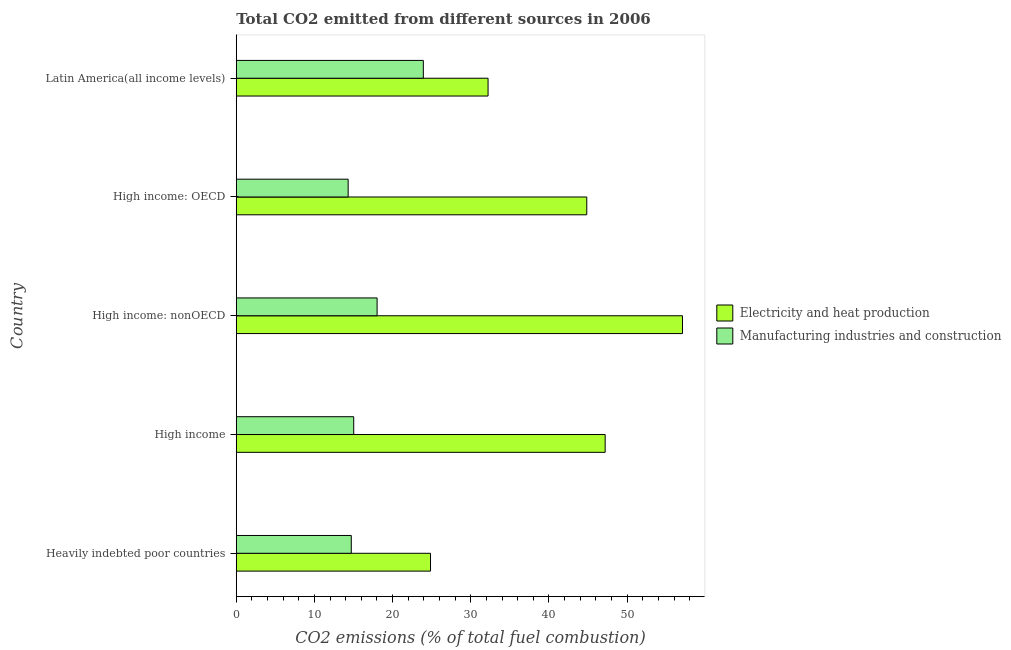How many different coloured bars are there?
Offer a very short reply. 2. How many groups of bars are there?
Your answer should be compact. 5. Are the number of bars per tick equal to the number of legend labels?
Provide a short and direct response. Yes. Are the number of bars on each tick of the Y-axis equal?
Offer a very short reply. Yes. How many bars are there on the 5th tick from the top?
Make the answer very short. 2. What is the label of the 4th group of bars from the top?
Provide a succinct answer. High income. In how many cases, is the number of bars for a given country not equal to the number of legend labels?
Offer a very short reply. 0. What is the co2 emissions due to electricity and heat production in Heavily indebted poor countries?
Your answer should be compact. 24.85. Across all countries, what is the maximum co2 emissions due to manufacturing industries?
Provide a short and direct response. 23.93. Across all countries, what is the minimum co2 emissions due to manufacturing industries?
Give a very brief answer. 14.31. In which country was the co2 emissions due to electricity and heat production maximum?
Give a very brief answer. High income: nonOECD. In which country was the co2 emissions due to electricity and heat production minimum?
Offer a very short reply. Heavily indebted poor countries. What is the total co2 emissions due to manufacturing industries in the graph?
Give a very brief answer. 86. What is the difference between the co2 emissions due to manufacturing industries in High income and the co2 emissions due to electricity and heat production in High income: nonOECD?
Offer a terse response. -42.06. What is the average co2 emissions due to electricity and heat production per country?
Ensure brevity in your answer.  41.24. What is the difference between the co2 emissions due to electricity and heat production and co2 emissions due to manufacturing industries in Heavily indebted poor countries?
Give a very brief answer. 10.14. In how many countries, is the co2 emissions due to electricity and heat production greater than 14 %?
Provide a short and direct response. 5. What is the ratio of the co2 emissions due to electricity and heat production in Heavily indebted poor countries to that in High income?
Ensure brevity in your answer.  0.53. Is the co2 emissions due to manufacturing industries in Heavily indebted poor countries less than that in High income: OECD?
Your response must be concise. No. What is the difference between the highest and the second highest co2 emissions due to electricity and heat production?
Your response must be concise. 9.89. What is the difference between the highest and the lowest co2 emissions due to manufacturing industries?
Give a very brief answer. 9.62. In how many countries, is the co2 emissions due to electricity and heat production greater than the average co2 emissions due to electricity and heat production taken over all countries?
Ensure brevity in your answer.  3. Is the sum of the co2 emissions due to manufacturing industries in High income: OECD and High income: nonOECD greater than the maximum co2 emissions due to electricity and heat production across all countries?
Offer a terse response. No. What does the 1st bar from the top in Heavily indebted poor countries represents?
Your answer should be compact. Manufacturing industries and construction. What does the 2nd bar from the bottom in High income represents?
Your response must be concise. Manufacturing industries and construction. Are all the bars in the graph horizontal?
Your answer should be very brief. Yes. How many countries are there in the graph?
Give a very brief answer. 5. What is the difference between two consecutive major ticks on the X-axis?
Your answer should be compact. 10. Are the values on the major ticks of X-axis written in scientific E-notation?
Provide a short and direct response. No. Does the graph contain grids?
Your answer should be compact. No. How many legend labels are there?
Provide a succinct answer. 2. How are the legend labels stacked?
Make the answer very short. Vertical. What is the title of the graph?
Your answer should be very brief. Total CO2 emitted from different sources in 2006. Does "Ages 15-24" appear as one of the legend labels in the graph?
Keep it short and to the point. No. What is the label or title of the X-axis?
Give a very brief answer. CO2 emissions (% of total fuel combustion). What is the label or title of the Y-axis?
Ensure brevity in your answer.  Country. What is the CO2 emissions (% of total fuel combustion) of Electricity and heat production in Heavily indebted poor countries?
Give a very brief answer. 24.85. What is the CO2 emissions (% of total fuel combustion) of Manufacturing industries and construction in Heavily indebted poor countries?
Keep it short and to the point. 14.71. What is the CO2 emissions (% of total fuel combustion) of Electricity and heat production in High income?
Provide a short and direct response. 47.19. What is the CO2 emissions (% of total fuel combustion) in Manufacturing industries and construction in High income?
Offer a terse response. 15.03. What is the CO2 emissions (% of total fuel combustion) in Electricity and heat production in High income: nonOECD?
Make the answer very short. 57.08. What is the CO2 emissions (% of total fuel combustion) in Manufacturing industries and construction in High income: nonOECD?
Provide a short and direct response. 18.02. What is the CO2 emissions (% of total fuel combustion) in Electricity and heat production in High income: OECD?
Offer a very short reply. 44.84. What is the CO2 emissions (% of total fuel combustion) of Manufacturing industries and construction in High income: OECD?
Your response must be concise. 14.31. What is the CO2 emissions (% of total fuel combustion) in Electricity and heat production in Latin America(all income levels)?
Make the answer very short. 32.21. What is the CO2 emissions (% of total fuel combustion) of Manufacturing industries and construction in Latin America(all income levels)?
Offer a terse response. 23.93. Across all countries, what is the maximum CO2 emissions (% of total fuel combustion) of Electricity and heat production?
Offer a terse response. 57.08. Across all countries, what is the maximum CO2 emissions (% of total fuel combustion) in Manufacturing industries and construction?
Offer a very short reply. 23.93. Across all countries, what is the minimum CO2 emissions (% of total fuel combustion) of Electricity and heat production?
Provide a succinct answer. 24.85. Across all countries, what is the minimum CO2 emissions (% of total fuel combustion) of Manufacturing industries and construction?
Keep it short and to the point. 14.31. What is the total CO2 emissions (% of total fuel combustion) of Electricity and heat production in the graph?
Keep it short and to the point. 206.18. What is the total CO2 emissions (% of total fuel combustion) in Manufacturing industries and construction in the graph?
Offer a terse response. 86. What is the difference between the CO2 emissions (% of total fuel combustion) of Electricity and heat production in Heavily indebted poor countries and that in High income?
Your answer should be compact. -22.34. What is the difference between the CO2 emissions (% of total fuel combustion) in Manufacturing industries and construction in Heavily indebted poor countries and that in High income?
Your answer should be very brief. -0.31. What is the difference between the CO2 emissions (% of total fuel combustion) in Electricity and heat production in Heavily indebted poor countries and that in High income: nonOECD?
Ensure brevity in your answer.  -32.23. What is the difference between the CO2 emissions (% of total fuel combustion) in Manufacturing industries and construction in Heavily indebted poor countries and that in High income: nonOECD?
Your answer should be compact. -3.3. What is the difference between the CO2 emissions (% of total fuel combustion) in Electricity and heat production in Heavily indebted poor countries and that in High income: OECD?
Your answer should be compact. -19.99. What is the difference between the CO2 emissions (% of total fuel combustion) of Manufacturing industries and construction in Heavily indebted poor countries and that in High income: OECD?
Keep it short and to the point. 0.4. What is the difference between the CO2 emissions (% of total fuel combustion) of Electricity and heat production in Heavily indebted poor countries and that in Latin America(all income levels)?
Make the answer very short. -7.36. What is the difference between the CO2 emissions (% of total fuel combustion) of Manufacturing industries and construction in Heavily indebted poor countries and that in Latin America(all income levels)?
Your response must be concise. -9.22. What is the difference between the CO2 emissions (% of total fuel combustion) in Electricity and heat production in High income and that in High income: nonOECD?
Ensure brevity in your answer.  -9.89. What is the difference between the CO2 emissions (% of total fuel combustion) in Manufacturing industries and construction in High income and that in High income: nonOECD?
Make the answer very short. -2.99. What is the difference between the CO2 emissions (% of total fuel combustion) of Electricity and heat production in High income and that in High income: OECD?
Provide a short and direct response. 2.35. What is the difference between the CO2 emissions (% of total fuel combustion) of Manufacturing industries and construction in High income and that in High income: OECD?
Offer a terse response. 0.71. What is the difference between the CO2 emissions (% of total fuel combustion) of Electricity and heat production in High income and that in Latin America(all income levels)?
Keep it short and to the point. 14.98. What is the difference between the CO2 emissions (% of total fuel combustion) of Manufacturing industries and construction in High income and that in Latin America(all income levels)?
Ensure brevity in your answer.  -8.91. What is the difference between the CO2 emissions (% of total fuel combustion) of Electricity and heat production in High income: nonOECD and that in High income: OECD?
Give a very brief answer. 12.24. What is the difference between the CO2 emissions (% of total fuel combustion) in Manufacturing industries and construction in High income: nonOECD and that in High income: OECD?
Offer a terse response. 3.7. What is the difference between the CO2 emissions (% of total fuel combustion) in Electricity and heat production in High income: nonOECD and that in Latin America(all income levels)?
Make the answer very short. 24.87. What is the difference between the CO2 emissions (% of total fuel combustion) in Manufacturing industries and construction in High income: nonOECD and that in Latin America(all income levels)?
Your response must be concise. -5.92. What is the difference between the CO2 emissions (% of total fuel combustion) of Electricity and heat production in High income: OECD and that in Latin America(all income levels)?
Give a very brief answer. 12.63. What is the difference between the CO2 emissions (% of total fuel combustion) of Manufacturing industries and construction in High income: OECD and that in Latin America(all income levels)?
Offer a terse response. -9.62. What is the difference between the CO2 emissions (% of total fuel combustion) of Electricity and heat production in Heavily indebted poor countries and the CO2 emissions (% of total fuel combustion) of Manufacturing industries and construction in High income?
Offer a terse response. 9.83. What is the difference between the CO2 emissions (% of total fuel combustion) in Electricity and heat production in Heavily indebted poor countries and the CO2 emissions (% of total fuel combustion) in Manufacturing industries and construction in High income: nonOECD?
Offer a very short reply. 6.84. What is the difference between the CO2 emissions (% of total fuel combustion) in Electricity and heat production in Heavily indebted poor countries and the CO2 emissions (% of total fuel combustion) in Manufacturing industries and construction in High income: OECD?
Make the answer very short. 10.54. What is the difference between the CO2 emissions (% of total fuel combustion) in Electricity and heat production in Heavily indebted poor countries and the CO2 emissions (% of total fuel combustion) in Manufacturing industries and construction in Latin America(all income levels)?
Ensure brevity in your answer.  0.92. What is the difference between the CO2 emissions (% of total fuel combustion) in Electricity and heat production in High income and the CO2 emissions (% of total fuel combustion) in Manufacturing industries and construction in High income: nonOECD?
Provide a succinct answer. 29.18. What is the difference between the CO2 emissions (% of total fuel combustion) of Electricity and heat production in High income and the CO2 emissions (% of total fuel combustion) of Manufacturing industries and construction in High income: OECD?
Offer a terse response. 32.88. What is the difference between the CO2 emissions (% of total fuel combustion) of Electricity and heat production in High income and the CO2 emissions (% of total fuel combustion) of Manufacturing industries and construction in Latin America(all income levels)?
Your answer should be very brief. 23.26. What is the difference between the CO2 emissions (% of total fuel combustion) in Electricity and heat production in High income: nonOECD and the CO2 emissions (% of total fuel combustion) in Manufacturing industries and construction in High income: OECD?
Provide a short and direct response. 42.77. What is the difference between the CO2 emissions (% of total fuel combustion) in Electricity and heat production in High income: nonOECD and the CO2 emissions (% of total fuel combustion) in Manufacturing industries and construction in Latin America(all income levels)?
Give a very brief answer. 33.15. What is the difference between the CO2 emissions (% of total fuel combustion) in Electricity and heat production in High income: OECD and the CO2 emissions (% of total fuel combustion) in Manufacturing industries and construction in Latin America(all income levels)?
Offer a terse response. 20.91. What is the average CO2 emissions (% of total fuel combustion) of Electricity and heat production per country?
Offer a very short reply. 41.24. What is the average CO2 emissions (% of total fuel combustion) of Manufacturing industries and construction per country?
Your answer should be compact. 17.2. What is the difference between the CO2 emissions (% of total fuel combustion) in Electricity and heat production and CO2 emissions (% of total fuel combustion) in Manufacturing industries and construction in Heavily indebted poor countries?
Your answer should be compact. 10.14. What is the difference between the CO2 emissions (% of total fuel combustion) of Electricity and heat production and CO2 emissions (% of total fuel combustion) of Manufacturing industries and construction in High income?
Provide a succinct answer. 32.17. What is the difference between the CO2 emissions (% of total fuel combustion) of Electricity and heat production and CO2 emissions (% of total fuel combustion) of Manufacturing industries and construction in High income: nonOECD?
Offer a terse response. 39.07. What is the difference between the CO2 emissions (% of total fuel combustion) in Electricity and heat production and CO2 emissions (% of total fuel combustion) in Manufacturing industries and construction in High income: OECD?
Your answer should be very brief. 30.52. What is the difference between the CO2 emissions (% of total fuel combustion) of Electricity and heat production and CO2 emissions (% of total fuel combustion) of Manufacturing industries and construction in Latin America(all income levels)?
Offer a very short reply. 8.28. What is the ratio of the CO2 emissions (% of total fuel combustion) of Electricity and heat production in Heavily indebted poor countries to that in High income?
Keep it short and to the point. 0.53. What is the ratio of the CO2 emissions (% of total fuel combustion) of Manufacturing industries and construction in Heavily indebted poor countries to that in High income?
Ensure brevity in your answer.  0.98. What is the ratio of the CO2 emissions (% of total fuel combustion) in Electricity and heat production in Heavily indebted poor countries to that in High income: nonOECD?
Your response must be concise. 0.44. What is the ratio of the CO2 emissions (% of total fuel combustion) in Manufacturing industries and construction in Heavily indebted poor countries to that in High income: nonOECD?
Offer a terse response. 0.82. What is the ratio of the CO2 emissions (% of total fuel combustion) of Electricity and heat production in Heavily indebted poor countries to that in High income: OECD?
Your answer should be compact. 0.55. What is the ratio of the CO2 emissions (% of total fuel combustion) in Manufacturing industries and construction in Heavily indebted poor countries to that in High income: OECD?
Give a very brief answer. 1.03. What is the ratio of the CO2 emissions (% of total fuel combustion) in Electricity and heat production in Heavily indebted poor countries to that in Latin America(all income levels)?
Offer a very short reply. 0.77. What is the ratio of the CO2 emissions (% of total fuel combustion) in Manufacturing industries and construction in Heavily indebted poor countries to that in Latin America(all income levels)?
Provide a short and direct response. 0.61. What is the ratio of the CO2 emissions (% of total fuel combustion) of Electricity and heat production in High income to that in High income: nonOECD?
Make the answer very short. 0.83. What is the ratio of the CO2 emissions (% of total fuel combustion) of Manufacturing industries and construction in High income to that in High income: nonOECD?
Give a very brief answer. 0.83. What is the ratio of the CO2 emissions (% of total fuel combustion) in Electricity and heat production in High income to that in High income: OECD?
Your answer should be compact. 1.05. What is the ratio of the CO2 emissions (% of total fuel combustion) of Manufacturing industries and construction in High income to that in High income: OECD?
Give a very brief answer. 1.05. What is the ratio of the CO2 emissions (% of total fuel combustion) of Electricity and heat production in High income to that in Latin America(all income levels)?
Provide a succinct answer. 1.47. What is the ratio of the CO2 emissions (% of total fuel combustion) of Manufacturing industries and construction in High income to that in Latin America(all income levels)?
Provide a short and direct response. 0.63. What is the ratio of the CO2 emissions (% of total fuel combustion) of Electricity and heat production in High income: nonOECD to that in High income: OECD?
Keep it short and to the point. 1.27. What is the ratio of the CO2 emissions (% of total fuel combustion) in Manufacturing industries and construction in High income: nonOECD to that in High income: OECD?
Your response must be concise. 1.26. What is the ratio of the CO2 emissions (% of total fuel combustion) in Electricity and heat production in High income: nonOECD to that in Latin America(all income levels)?
Ensure brevity in your answer.  1.77. What is the ratio of the CO2 emissions (% of total fuel combustion) of Manufacturing industries and construction in High income: nonOECD to that in Latin America(all income levels)?
Your answer should be compact. 0.75. What is the ratio of the CO2 emissions (% of total fuel combustion) of Electricity and heat production in High income: OECD to that in Latin America(all income levels)?
Offer a very short reply. 1.39. What is the ratio of the CO2 emissions (% of total fuel combustion) of Manufacturing industries and construction in High income: OECD to that in Latin America(all income levels)?
Your answer should be compact. 0.6. What is the difference between the highest and the second highest CO2 emissions (% of total fuel combustion) of Electricity and heat production?
Your response must be concise. 9.89. What is the difference between the highest and the second highest CO2 emissions (% of total fuel combustion) in Manufacturing industries and construction?
Provide a succinct answer. 5.92. What is the difference between the highest and the lowest CO2 emissions (% of total fuel combustion) of Electricity and heat production?
Your response must be concise. 32.23. What is the difference between the highest and the lowest CO2 emissions (% of total fuel combustion) of Manufacturing industries and construction?
Your answer should be compact. 9.62. 